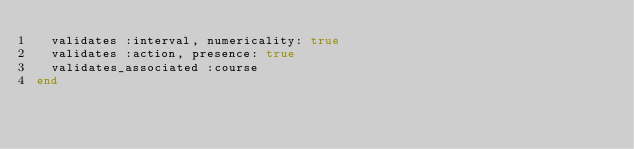Convert code to text. <code><loc_0><loc_0><loc_500><loc_500><_Ruby_>  validates :interval, numericality: true
  validates :action, presence: true
  validates_associated :course
end
</code> 